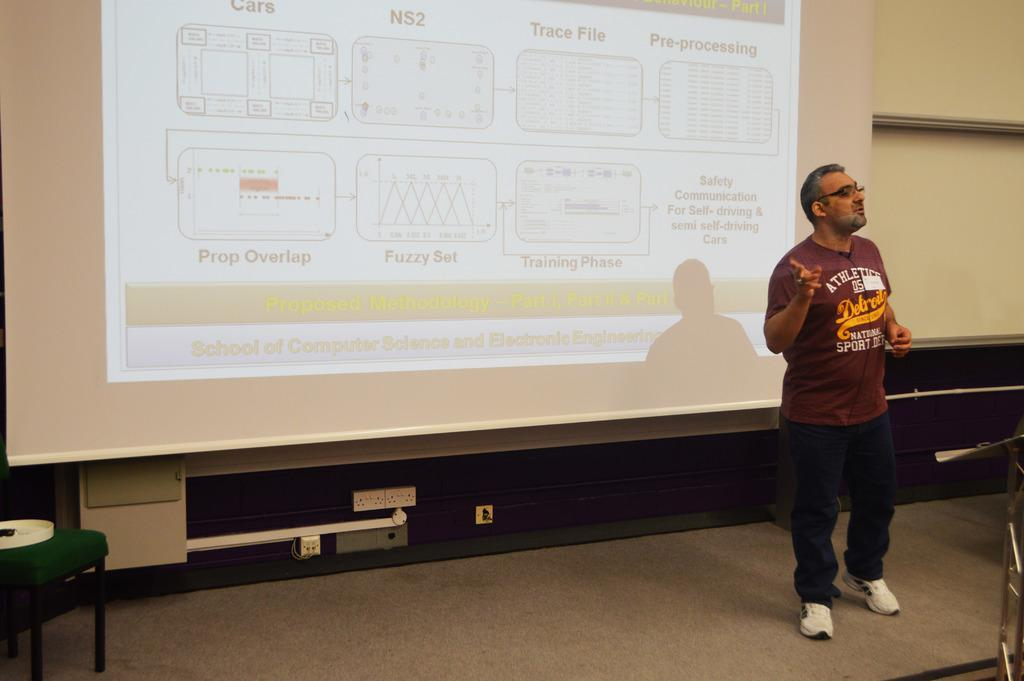<image>
Summarize the visual content of the image. The top left diagram on the screen is labeled "cars". 